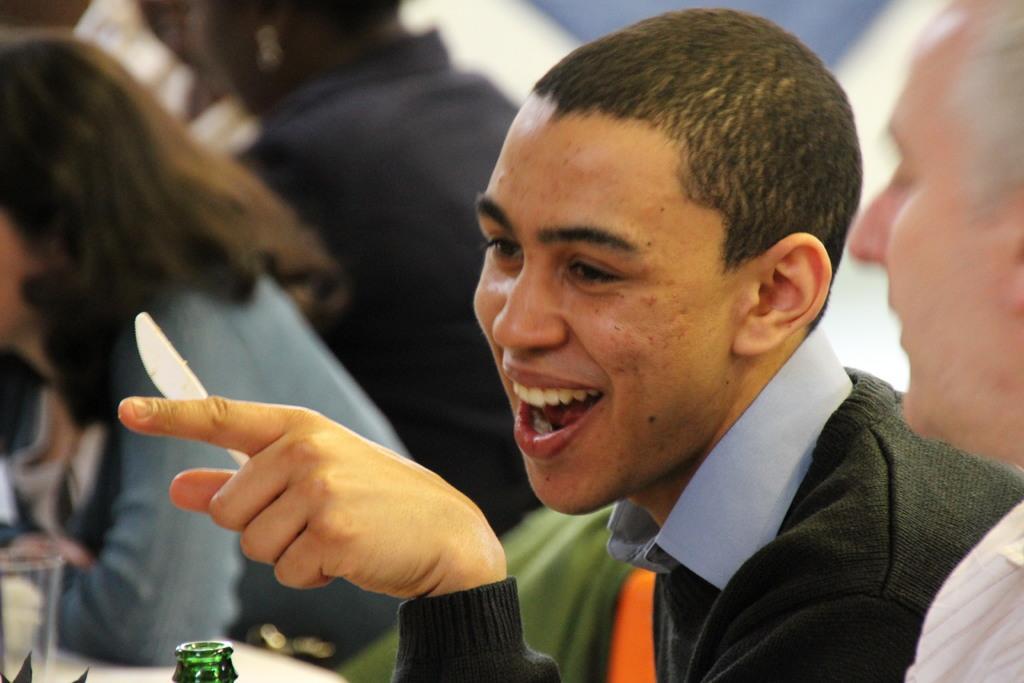Could you give a brief overview of what you see in this image? In the image there are few people and only one person is clearly visible in the image he is holding a knife in his left and and he is smiling. There is a bottle and front of him and there is another man beside that person and the background is blurry. 